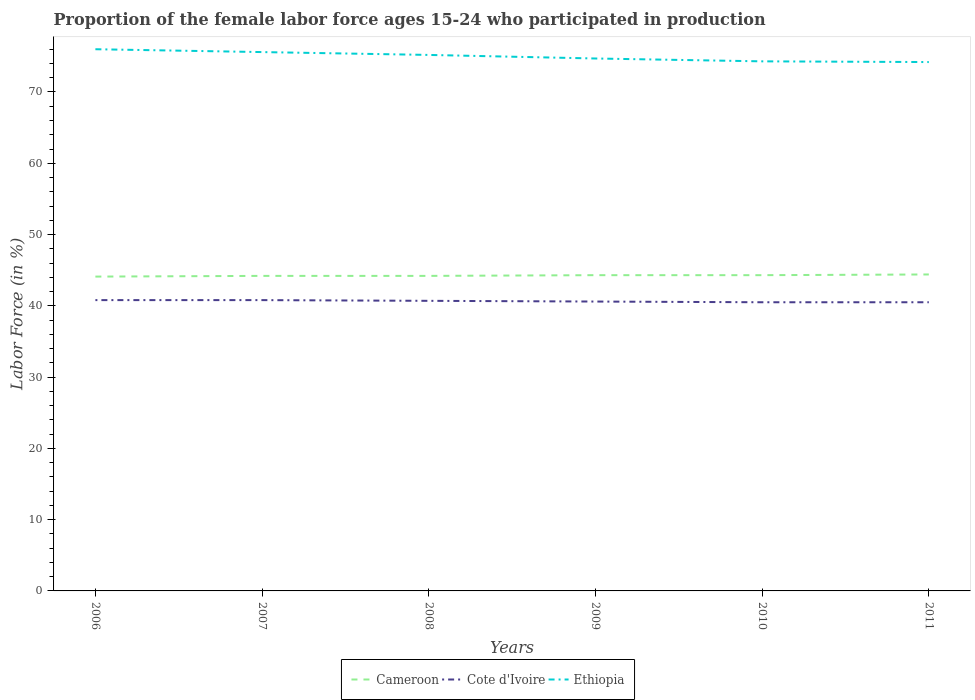How many different coloured lines are there?
Your response must be concise. 3. Does the line corresponding to Cote d'Ivoire intersect with the line corresponding to Cameroon?
Offer a very short reply. No. Across all years, what is the maximum proportion of the female labor force who participated in production in Ethiopia?
Keep it short and to the point. 74.2. In which year was the proportion of the female labor force who participated in production in Cameroon maximum?
Make the answer very short. 2006. What is the total proportion of the female labor force who participated in production in Ethiopia in the graph?
Make the answer very short. 1.3. What is the difference between the highest and the second highest proportion of the female labor force who participated in production in Ethiopia?
Your response must be concise. 1.8. How many lines are there?
Make the answer very short. 3. How many years are there in the graph?
Your answer should be compact. 6. What is the difference between two consecutive major ticks on the Y-axis?
Make the answer very short. 10. Does the graph contain any zero values?
Provide a short and direct response. No. Does the graph contain grids?
Give a very brief answer. No. Where does the legend appear in the graph?
Your answer should be compact. Bottom center. How are the legend labels stacked?
Keep it short and to the point. Horizontal. What is the title of the graph?
Keep it short and to the point. Proportion of the female labor force ages 15-24 who participated in production. What is the label or title of the X-axis?
Provide a short and direct response. Years. What is the label or title of the Y-axis?
Your answer should be compact. Labor Force (in %). What is the Labor Force (in %) of Cameroon in 2006?
Make the answer very short. 44.1. What is the Labor Force (in %) of Cote d'Ivoire in 2006?
Make the answer very short. 40.8. What is the Labor Force (in %) in Cameroon in 2007?
Provide a succinct answer. 44.2. What is the Labor Force (in %) in Cote d'Ivoire in 2007?
Make the answer very short. 40.8. What is the Labor Force (in %) of Ethiopia in 2007?
Offer a very short reply. 75.6. What is the Labor Force (in %) in Cameroon in 2008?
Offer a very short reply. 44.2. What is the Labor Force (in %) in Cote d'Ivoire in 2008?
Offer a terse response. 40.7. What is the Labor Force (in %) in Ethiopia in 2008?
Give a very brief answer. 75.2. What is the Labor Force (in %) in Cameroon in 2009?
Your answer should be very brief. 44.3. What is the Labor Force (in %) in Cote d'Ivoire in 2009?
Your response must be concise. 40.6. What is the Labor Force (in %) of Ethiopia in 2009?
Keep it short and to the point. 74.7. What is the Labor Force (in %) of Cameroon in 2010?
Your answer should be compact. 44.3. What is the Labor Force (in %) of Cote d'Ivoire in 2010?
Provide a succinct answer. 40.5. What is the Labor Force (in %) of Ethiopia in 2010?
Keep it short and to the point. 74.3. What is the Labor Force (in %) of Cameroon in 2011?
Your response must be concise. 44.4. What is the Labor Force (in %) in Cote d'Ivoire in 2011?
Give a very brief answer. 40.5. What is the Labor Force (in %) of Ethiopia in 2011?
Provide a short and direct response. 74.2. Across all years, what is the maximum Labor Force (in %) in Cameroon?
Provide a short and direct response. 44.4. Across all years, what is the maximum Labor Force (in %) of Cote d'Ivoire?
Your answer should be very brief. 40.8. Across all years, what is the minimum Labor Force (in %) of Cameroon?
Your answer should be compact. 44.1. Across all years, what is the minimum Labor Force (in %) of Cote d'Ivoire?
Provide a short and direct response. 40.5. Across all years, what is the minimum Labor Force (in %) of Ethiopia?
Offer a very short reply. 74.2. What is the total Labor Force (in %) in Cameroon in the graph?
Your response must be concise. 265.5. What is the total Labor Force (in %) in Cote d'Ivoire in the graph?
Keep it short and to the point. 243.9. What is the total Labor Force (in %) in Ethiopia in the graph?
Ensure brevity in your answer.  450. What is the difference between the Labor Force (in %) in Cameroon in 2006 and that in 2007?
Give a very brief answer. -0.1. What is the difference between the Labor Force (in %) of Ethiopia in 2006 and that in 2007?
Offer a terse response. 0.4. What is the difference between the Labor Force (in %) of Cameroon in 2006 and that in 2008?
Give a very brief answer. -0.1. What is the difference between the Labor Force (in %) of Ethiopia in 2006 and that in 2008?
Make the answer very short. 0.8. What is the difference between the Labor Force (in %) in Cameroon in 2006 and that in 2009?
Your answer should be compact. -0.2. What is the difference between the Labor Force (in %) in Cote d'Ivoire in 2006 and that in 2010?
Make the answer very short. 0.3. What is the difference between the Labor Force (in %) in Ethiopia in 2006 and that in 2010?
Offer a very short reply. 1.7. What is the difference between the Labor Force (in %) in Cameroon in 2006 and that in 2011?
Provide a short and direct response. -0.3. What is the difference between the Labor Force (in %) in Cote d'Ivoire in 2006 and that in 2011?
Your response must be concise. 0.3. What is the difference between the Labor Force (in %) in Ethiopia in 2006 and that in 2011?
Keep it short and to the point. 1.8. What is the difference between the Labor Force (in %) in Cameroon in 2007 and that in 2008?
Ensure brevity in your answer.  0. What is the difference between the Labor Force (in %) of Ethiopia in 2007 and that in 2008?
Your answer should be very brief. 0.4. What is the difference between the Labor Force (in %) of Cameroon in 2007 and that in 2009?
Your response must be concise. -0.1. What is the difference between the Labor Force (in %) of Cote d'Ivoire in 2007 and that in 2009?
Make the answer very short. 0.2. What is the difference between the Labor Force (in %) of Ethiopia in 2007 and that in 2010?
Give a very brief answer. 1.3. What is the difference between the Labor Force (in %) in Cameroon in 2007 and that in 2011?
Offer a very short reply. -0.2. What is the difference between the Labor Force (in %) in Cote d'Ivoire in 2007 and that in 2011?
Offer a very short reply. 0.3. What is the difference between the Labor Force (in %) in Cameroon in 2008 and that in 2009?
Give a very brief answer. -0.1. What is the difference between the Labor Force (in %) of Cote d'Ivoire in 2008 and that in 2009?
Your answer should be very brief. 0.1. What is the difference between the Labor Force (in %) of Ethiopia in 2008 and that in 2009?
Make the answer very short. 0.5. What is the difference between the Labor Force (in %) of Cameroon in 2008 and that in 2010?
Make the answer very short. -0.1. What is the difference between the Labor Force (in %) in Ethiopia in 2008 and that in 2010?
Provide a short and direct response. 0.9. What is the difference between the Labor Force (in %) in Cameroon in 2008 and that in 2011?
Provide a short and direct response. -0.2. What is the difference between the Labor Force (in %) of Cote d'Ivoire in 2008 and that in 2011?
Your answer should be compact. 0.2. What is the difference between the Labor Force (in %) in Cameroon in 2009 and that in 2010?
Your answer should be compact. 0. What is the difference between the Labor Force (in %) in Cote d'Ivoire in 2009 and that in 2010?
Offer a very short reply. 0.1. What is the difference between the Labor Force (in %) of Ethiopia in 2009 and that in 2010?
Your response must be concise. 0.4. What is the difference between the Labor Force (in %) in Cameroon in 2009 and that in 2011?
Offer a terse response. -0.1. What is the difference between the Labor Force (in %) of Cote d'Ivoire in 2009 and that in 2011?
Offer a very short reply. 0.1. What is the difference between the Labor Force (in %) of Cameroon in 2010 and that in 2011?
Your answer should be very brief. -0.1. What is the difference between the Labor Force (in %) of Cameroon in 2006 and the Labor Force (in %) of Ethiopia in 2007?
Your answer should be very brief. -31.5. What is the difference between the Labor Force (in %) in Cote d'Ivoire in 2006 and the Labor Force (in %) in Ethiopia in 2007?
Make the answer very short. -34.8. What is the difference between the Labor Force (in %) of Cameroon in 2006 and the Labor Force (in %) of Cote d'Ivoire in 2008?
Keep it short and to the point. 3.4. What is the difference between the Labor Force (in %) in Cameroon in 2006 and the Labor Force (in %) in Ethiopia in 2008?
Make the answer very short. -31.1. What is the difference between the Labor Force (in %) in Cote d'Ivoire in 2006 and the Labor Force (in %) in Ethiopia in 2008?
Keep it short and to the point. -34.4. What is the difference between the Labor Force (in %) of Cameroon in 2006 and the Labor Force (in %) of Ethiopia in 2009?
Make the answer very short. -30.6. What is the difference between the Labor Force (in %) in Cote d'Ivoire in 2006 and the Labor Force (in %) in Ethiopia in 2009?
Make the answer very short. -33.9. What is the difference between the Labor Force (in %) in Cameroon in 2006 and the Labor Force (in %) in Cote d'Ivoire in 2010?
Offer a very short reply. 3.6. What is the difference between the Labor Force (in %) of Cameroon in 2006 and the Labor Force (in %) of Ethiopia in 2010?
Your answer should be compact. -30.2. What is the difference between the Labor Force (in %) of Cote d'Ivoire in 2006 and the Labor Force (in %) of Ethiopia in 2010?
Your answer should be compact. -33.5. What is the difference between the Labor Force (in %) of Cameroon in 2006 and the Labor Force (in %) of Ethiopia in 2011?
Provide a short and direct response. -30.1. What is the difference between the Labor Force (in %) of Cote d'Ivoire in 2006 and the Labor Force (in %) of Ethiopia in 2011?
Your answer should be very brief. -33.4. What is the difference between the Labor Force (in %) of Cameroon in 2007 and the Labor Force (in %) of Cote d'Ivoire in 2008?
Offer a very short reply. 3.5. What is the difference between the Labor Force (in %) of Cameroon in 2007 and the Labor Force (in %) of Ethiopia in 2008?
Provide a short and direct response. -31. What is the difference between the Labor Force (in %) in Cote d'Ivoire in 2007 and the Labor Force (in %) in Ethiopia in 2008?
Your answer should be compact. -34.4. What is the difference between the Labor Force (in %) of Cameroon in 2007 and the Labor Force (in %) of Cote d'Ivoire in 2009?
Offer a very short reply. 3.6. What is the difference between the Labor Force (in %) in Cameroon in 2007 and the Labor Force (in %) in Ethiopia in 2009?
Provide a short and direct response. -30.5. What is the difference between the Labor Force (in %) of Cote d'Ivoire in 2007 and the Labor Force (in %) of Ethiopia in 2009?
Offer a very short reply. -33.9. What is the difference between the Labor Force (in %) in Cameroon in 2007 and the Labor Force (in %) in Ethiopia in 2010?
Your response must be concise. -30.1. What is the difference between the Labor Force (in %) of Cote d'Ivoire in 2007 and the Labor Force (in %) of Ethiopia in 2010?
Give a very brief answer. -33.5. What is the difference between the Labor Force (in %) of Cameroon in 2007 and the Labor Force (in %) of Ethiopia in 2011?
Offer a terse response. -30. What is the difference between the Labor Force (in %) of Cote d'Ivoire in 2007 and the Labor Force (in %) of Ethiopia in 2011?
Offer a very short reply. -33.4. What is the difference between the Labor Force (in %) in Cameroon in 2008 and the Labor Force (in %) in Cote d'Ivoire in 2009?
Offer a terse response. 3.6. What is the difference between the Labor Force (in %) in Cameroon in 2008 and the Labor Force (in %) in Ethiopia in 2009?
Provide a succinct answer. -30.5. What is the difference between the Labor Force (in %) in Cote d'Ivoire in 2008 and the Labor Force (in %) in Ethiopia in 2009?
Give a very brief answer. -34. What is the difference between the Labor Force (in %) in Cameroon in 2008 and the Labor Force (in %) in Cote d'Ivoire in 2010?
Provide a succinct answer. 3.7. What is the difference between the Labor Force (in %) of Cameroon in 2008 and the Labor Force (in %) of Ethiopia in 2010?
Keep it short and to the point. -30.1. What is the difference between the Labor Force (in %) in Cote d'Ivoire in 2008 and the Labor Force (in %) in Ethiopia in 2010?
Offer a very short reply. -33.6. What is the difference between the Labor Force (in %) in Cote d'Ivoire in 2008 and the Labor Force (in %) in Ethiopia in 2011?
Keep it short and to the point. -33.5. What is the difference between the Labor Force (in %) in Cameroon in 2009 and the Labor Force (in %) in Ethiopia in 2010?
Your answer should be compact. -30. What is the difference between the Labor Force (in %) of Cote d'Ivoire in 2009 and the Labor Force (in %) of Ethiopia in 2010?
Offer a terse response. -33.7. What is the difference between the Labor Force (in %) in Cameroon in 2009 and the Labor Force (in %) in Cote d'Ivoire in 2011?
Your answer should be very brief. 3.8. What is the difference between the Labor Force (in %) of Cameroon in 2009 and the Labor Force (in %) of Ethiopia in 2011?
Offer a very short reply. -29.9. What is the difference between the Labor Force (in %) in Cote d'Ivoire in 2009 and the Labor Force (in %) in Ethiopia in 2011?
Your answer should be compact. -33.6. What is the difference between the Labor Force (in %) in Cameroon in 2010 and the Labor Force (in %) in Ethiopia in 2011?
Your response must be concise. -29.9. What is the difference between the Labor Force (in %) in Cote d'Ivoire in 2010 and the Labor Force (in %) in Ethiopia in 2011?
Your answer should be very brief. -33.7. What is the average Labor Force (in %) of Cameroon per year?
Offer a terse response. 44.25. What is the average Labor Force (in %) in Cote d'Ivoire per year?
Offer a very short reply. 40.65. What is the average Labor Force (in %) in Ethiopia per year?
Give a very brief answer. 75. In the year 2006, what is the difference between the Labor Force (in %) of Cameroon and Labor Force (in %) of Ethiopia?
Give a very brief answer. -31.9. In the year 2006, what is the difference between the Labor Force (in %) of Cote d'Ivoire and Labor Force (in %) of Ethiopia?
Provide a short and direct response. -35.2. In the year 2007, what is the difference between the Labor Force (in %) in Cameroon and Labor Force (in %) in Ethiopia?
Your answer should be very brief. -31.4. In the year 2007, what is the difference between the Labor Force (in %) of Cote d'Ivoire and Labor Force (in %) of Ethiopia?
Ensure brevity in your answer.  -34.8. In the year 2008, what is the difference between the Labor Force (in %) of Cameroon and Labor Force (in %) of Ethiopia?
Your answer should be compact. -31. In the year 2008, what is the difference between the Labor Force (in %) in Cote d'Ivoire and Labor Force (in %) in Ethiopia?
Make the answer very short. -34.5. In the year 2009, what is the difference between the Labor Force (in %) in Cameroon and Labor Force (in %) in Ethiopia?
Your answer should be very brief. -30.4. In the year 2009, what is the difference between the Labor Force (in %) in Cote d'Ivoire and Labor Force (in %) in Ethiopia?
Your answer should be compact. -34.1. In the year 2010, what is the difference between the Labor Force (in %) in Cote d'Ivoire and Labor Force (in %) in Ethiopia?
Your answer should be very brief. -33.8. In the year 2011, what is the difference between the Labor Force (in %) in Cameroon and Labor Force (in %) in Ethiopia?
Provide a short and direct response. -29.8. In the year 2011, what is the difference between the Labor Force (in %) of Cote d'Ivoire and Labor Force (in %) of Ethiopia?
Provide a short and direct response. -33.7. What is the ratio of the Labor Force (in %) in Cameroon in 2006 to that in 2007?
Make the answer very short. 1. What is the ratio of the Labor Force (in %) in Cameroon in 2006 to that in 2008?
Make the answer very short. 1. What is the ratio of the Labor Force (in %) in Ethiopia in 2006 to that in 2008?
Offer a terse response. 1.01. What is the ratio of the Labor Force (in %) in Cote d'Ivoire in 2006 to that in 2009?
Make the answer very short. 1. What is the ratio of the Labor Force (in %) in Ethiopia in 2006 to that in 2009?
Keep it short and to the point. 1.02. What is the ratio of the Labor Force (in %) in Cote d'Ivoire in 2006 to that in 2010?
Offer a very short reply. 1.01. What is the ratio of the Labor Force (in %) of Ethiopia in 2006 to that in 2010?
Ensure brevity in your answer.  1.02. What is the ratio of the Labor Force (in %) of Cameroon in 2006 to that in 2011?
Your answer should be compact. 0.99. What is the ratio of the Labor Force (in %) in Cote d'Ivoire in 2006 to that in 2011?
Give a very brief answer. 1.01. What is the ratio of the Labor Force (in %) in Ethiopia in 2006 to that in 2011?
Keep it short and to the point. 1.02. What is the ratio of the Labor Force (in %) of Cameroon in 2007 to that in 2008?
Your answer should be very brief. 1. What is the ratio of the Labor Force (in %) of Cote d'Ivoire in 2007 to that in 2008?
Make the answer very short. 1. What is the ratio of the Labor Force (in %) of Ethiopia in 2007 to that in 2008?
Offer a terse response. 1.01. What is the ratio of the Labor Force (in %) in Cote d'Ivoire in 2007 to that in 2009?
Give a very brief answer. 1. What is the ratio of the Labor Force (in %) of Ethiopia in 2007 to that in 2009?
Make the answer very short. 1.01. What is the ratio of the Labor Force (in %) of Cameroon in 2007 to that in 2010?
Your answer should be very brief. 1. What is the ratio of the Labor Force (in %) in Cote d'Ivoire in 2007 to that in 2010?
Provide a short and direct response. 1.01. What is the ratio of the Labor Force (in %) of Ethiopia in 2007 to that in 2010?
Offer a terse response. 1.02. What is the ratio of the Labor Force (in %) of Cote d'Ivoire in 2007 to that in 2011?
Offer a terse response. 1.01. What is the ratio of the Labor Force (in %) of Ethiopia in 2007 to that in 2011?
Provide a short and direct response. 1.02. What is the ratio of the Labor Force (in %) in Cote d'Ivoire in 2008 to that in 2009?
Provide a succinct answer. 1. What is the ratio of the Labor Force (in %) in Ethiopia in 2008 to that in 2009?
Keep it short and to the point. 1.01. What is the ratio of the Labor Force (in %) of Ethiopia in 2008 to that in 2010?
Your answer should be very brief. 1.01. What is the ratio of the Labor Force (in %) of Cameroon in 2008 to that in 2011?
Your answer should be very brief. 1. What is the ratio of the Labor Force (in %) in Cote d'Ivoire in 2008 to that in 2011?
Provide a short and direct response. 1. What is the ratio of the Labor Force (in %) of Ethiopia in 2008 to that in 2011?
Keep it short and to the point. 1.01. What is the ratio of the Labor Force (in %) in Cameroon in 2009 to that in 2010?
Offer a terse response. 1. What is the ratio of the Labor Force (in %) in Ethiopia in 2009 to that in 2010?
Ensure brevity in your answer.  1.01. What is the ratio of the Labor Force (in %) of Cameroon in 2009 to that in 2011?
Offer a very short reply. 1. What is the ratio of the Labor Force (in %) in Cameroon in 2010 to that in 2011?
Offer a terse response. 1. What is the ratio of the Labor Force (in %) of Cote d'Ivoire in 2010 to that in 2011?
Provide a succinct answer. 1. What is the ratio of the Labor Force (in %) in Ethiopia in 2010 to that in 2011?
Your answer should be compact. 1. What is the difference between the highest and the second highest Labor Force (in %) of Cameroon?
Give a very brief answer. 0.1. What is the difference between the highest and the second highest Labor Force (in %) in Cote d'Ivoire?
Keep it short and to the point. 0. What is the difference between the highest and the second highest Labor Force (in %) of Ethiopia?
Make the answer very short. 0.4. What is the difference between the highest and the lowest Labor Force (in %) of Ethiopia?
Give a very brief answer. 1.8. 